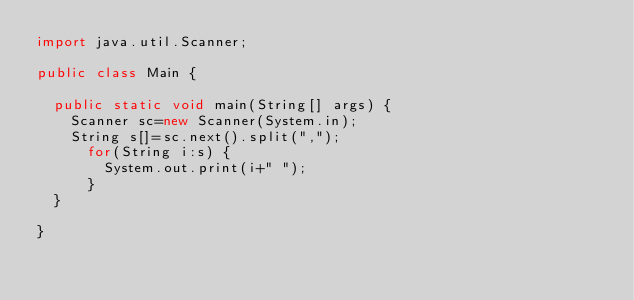<code> <loc_0><loc_0><loc_500><loc_500><_Java_>import java.util.Scanner;

public class Main {

	public static void main(String[] args) {
		Scanner sc=new Scanner(System.in);
		String s[]=sc.next().split(",");
			for(String i:s) {
				System.out.print(i+" ");
			}
	}

}
</code> 